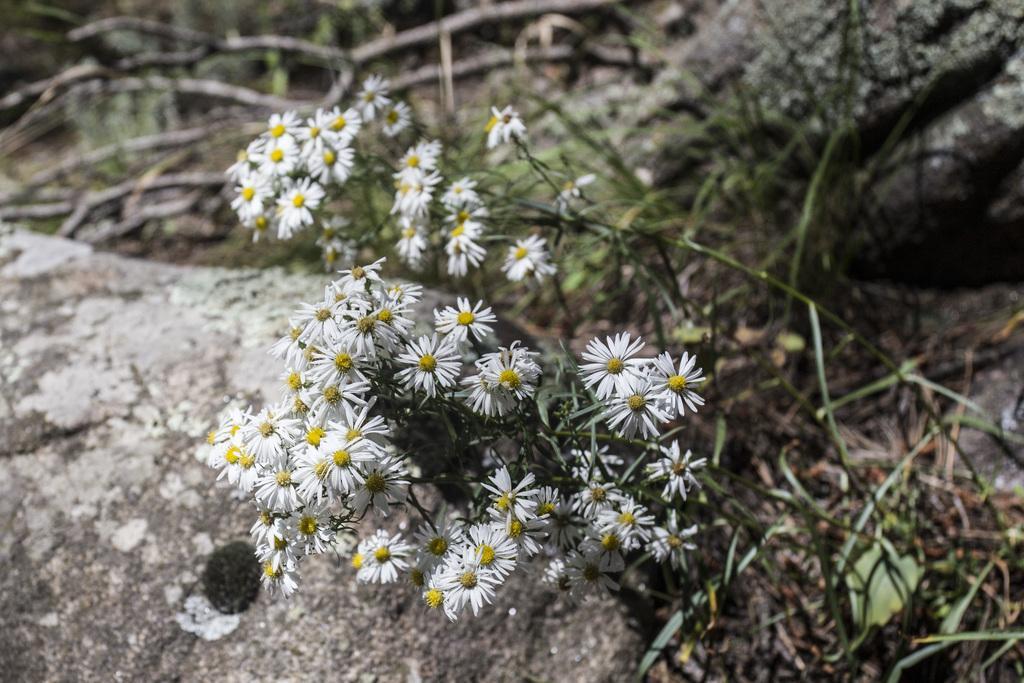In one or two sentences, can you explain what this image depicts? This image consists of a plant. It has leaves and flowers. Flowers are in white color. 